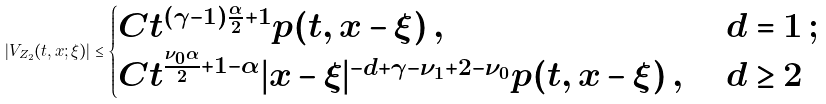<formula> <loc_0><loc_0><loc_500><loc_500>| V _ { Z _ { 2 } } ( t , x ; \xi ) | \leq \begin{cases} C t ^ { ( \gamma - 1 ) \frac { \alpha } { 2 } + 1 } p ( t , x - \xi ) \, , & \ d = 1 \, ; \\ C t ^ { \frac { \nu _ { 0 } \alpha } { 2 } + 1 - \alpha } | x - \xi | ^ { - d + \gamma - \nu _ { 1 } + 2 - \nu _ { 0 } } p ( t , x - \xi ) \, , & \ d \geq 2 \\ \end{cases}</formula> 